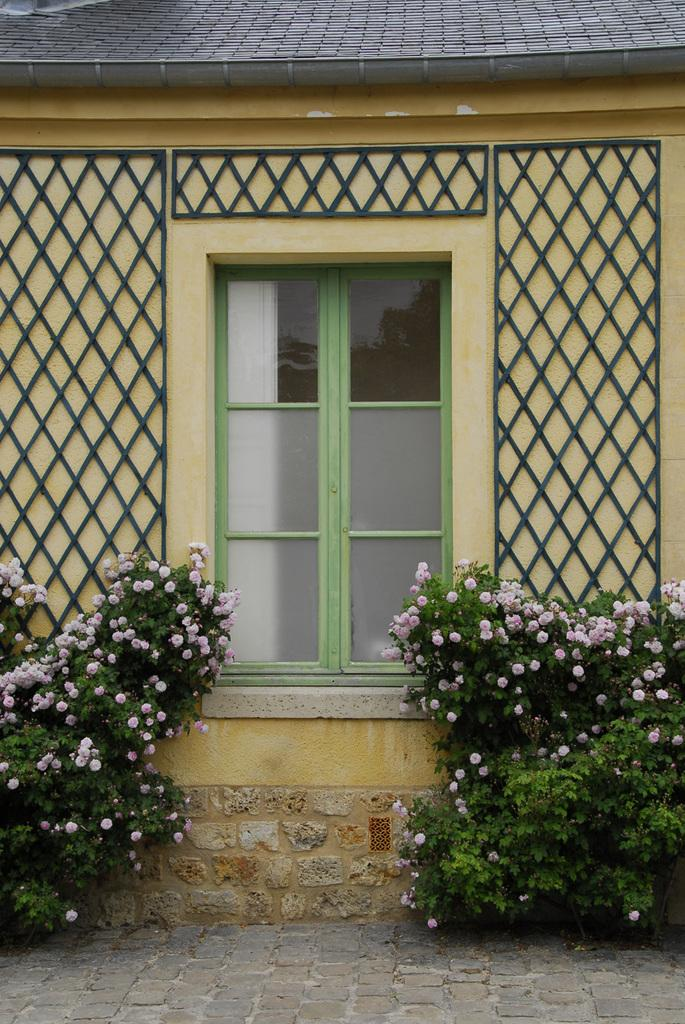What type of structure is visible in the image? The image contains a wall with windows. Are there any decorations or objects on the wall? Yes, there are objects on the wall. What type of vegetation can be seen in the image? There are plants with flowers in the image. What is visible beneath the wall and objects in the image? The ground is visible in the image. What is located at the top of the image? There is an object at the top of the image. What advice does the grandfather give to the person in the image? There is no grandfather or person present in the image, so it is not possible to answer that question. 